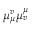<formula> <loc_0><loc_0><loc_500><loc_500>\mu _ { \mu } ^ { v } \mu _ { v } ^ { \mu }</formula> 